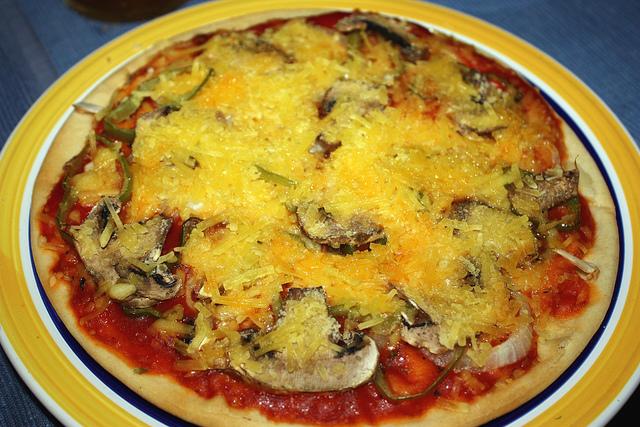Is there cheese on this?
Give a very brief answer. Yes. Is the meal for one person?
Give a very brief answer. Yes. Is the food warm?
Quick response, please. Yes. 